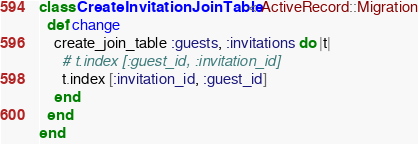<code> <loc_0><loc_0><loc_500><loc_500><_Ruby_>class CreateInvitationJoinTable < ActiveRecord::Migration
  def change
    create_join_table :guests, :invitations do |t|
      # t.index [:guest_id, :invitation_id]
      t.index [:invitation_id, :guest_id]
    end
  end
end
</code> 